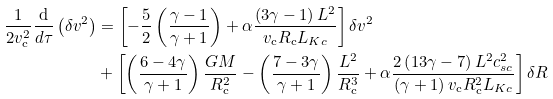Convert formula to latex. <formula><loc_0><loc_0><loc_500><loc_500>\frac { 1 } { 2 v _ { \mathrm c } ^ { 2 } } \frac { \mathrm d } { d \tau } \left ( \delta v ^ { 2 } \right ) & = \left [ - \frac { 5 } { 2 } \left ( \frac { \gamma - 1 } { \gamma + 1 } \right ) + \alpha \frac { \left ( 3 \gamma - 1 \right ) L ^ { 2 } } { v _ { \mathrm c } R _ { \mathrm c } L _ { K c } } \right ] { \delta } v ^ { 2 } \\ & + \left [ \left ( \frac { 6 - 4 { \gamma } } { \gamma + 1 } \right ) \frac { G M } { R _ { \mathrm c } ^ { 2 } } - \left ( \frac { 7 - 3 \gamma } { \gamma + 1 } \right ) \frac { L ^ { 2 } } { R _ { \mathrm c } ^ { 3 } } + \alpha \frac { 2 \left ( 1 3 \gamma - 7 \right ) L ^ { 2 } c _ { s c } ^ { 2 } } { \left ( \gamma + 1 \right ) v _ { \mathrm c } R _ { \mathrm c } ^ { 2 } L _ { K c } } \right ] \delta R</formula> 